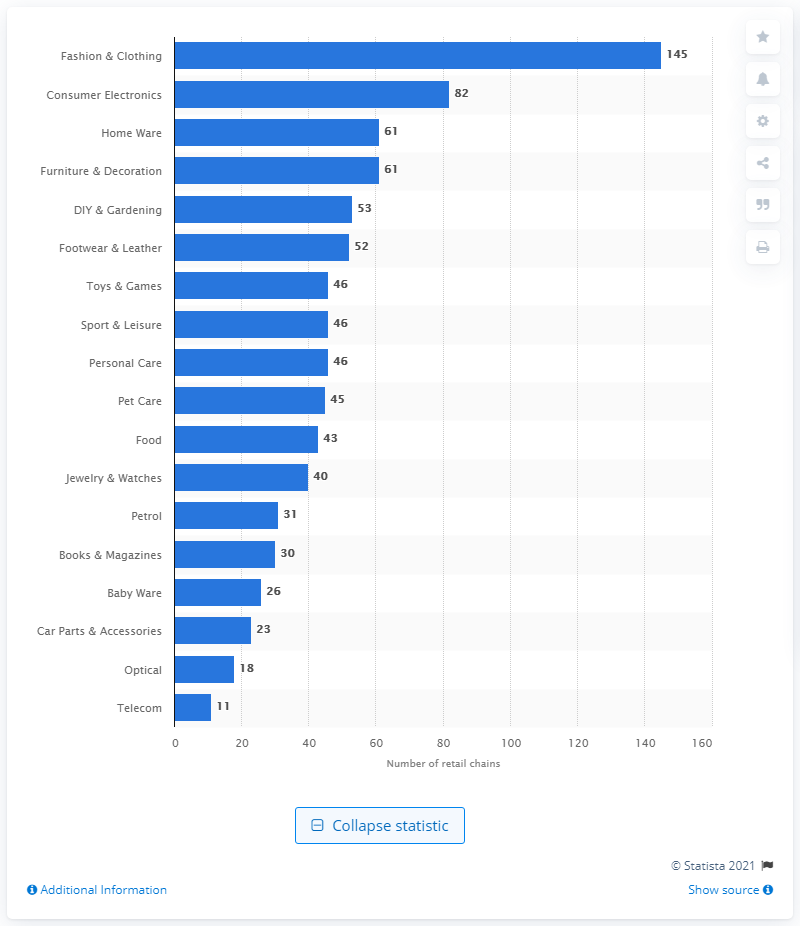Indicate a few pertinent items in this graphic. As of 2020, the telecoms sector had a total of 11 retail chains. 